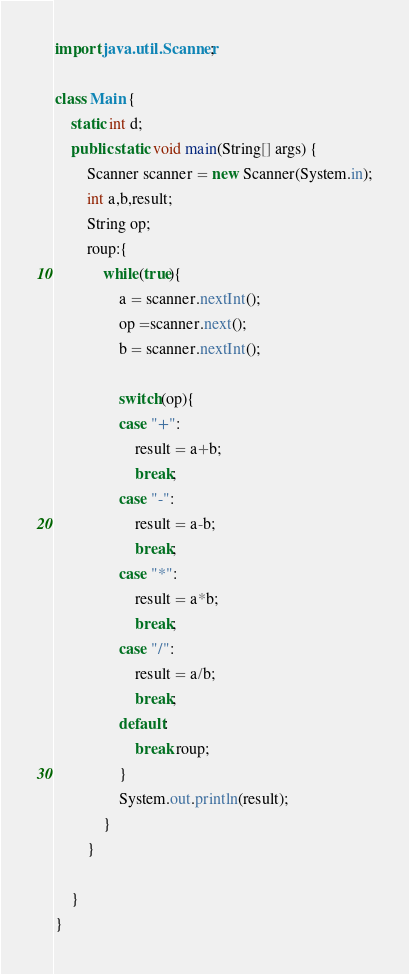<code> <loc_0><loc_0><loc_500><loc_500><_Java_>import java.util.Scanner;

class Main {
	static int d;
	public static void main(String[] args) {
		Scanner scanner = new Scanner(System.in);
		int a,b,result;
		String op;
		roup:{
			while(true){
				a = scanner.nextInt();
				op =scanner.next();
				b = scanner.nextInt();

				switch(op){
				case "+":
					result = a+b;
					break;
				case "-":
					result = a-b;
					break;
				case "*":
					result = a*b;
					break;
				case "/":
					result = a/b;
					break;
				default:
					break roup;
				}
				System.out.println(result);
			}
		}

	}
}
</code> 